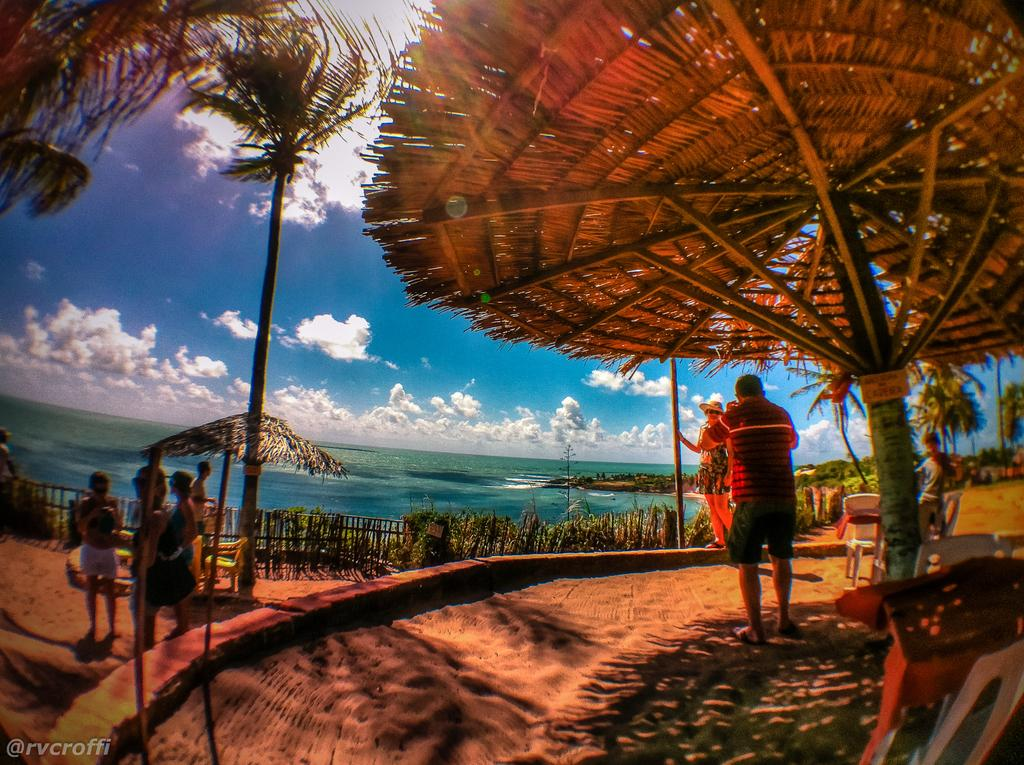What is the main subject of subject of the image? There is a person standing in the image. Are there any other people in the image? Yes, there are other persons standing on the left side of the image. What type of vegetation can be seen in the image? There are plants with a green color in the image. What can be seen in the background of the image? There is water visible in the background of the image. What is the color of the sky in the image? The sky is blue and white in color. What type of robin is sitting on the person's shoulder in the image? There is no robin present in the image; it only features a person and other individuals standing nearby. What is the size of the breakfast being served in the image? There is no breakfast visible in the image; it only features people and plants. 